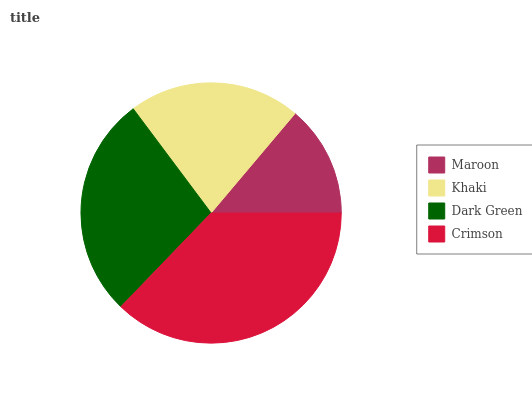Is Maroon the minimum?
Answer yes or no. Yes. Is Crimson the maximum?
Answer yes or no. Yes. Is Khaki the minimum?
Answer yes or no. No. Is Khaki the maximum?
Answer yes or no. No. Is Khaki greater than Maroon?
Answer yes or no. Yes. Is Maroon less than Khaki?
Answer yes or no. Yes. Is Maroon greater than Khaki?
Answer yes or no. No. Is Khaki less than Maroon?
Answer yes or no. No. Is Dark Green the high median?
Answer yes or no. Yes. Is Khaki the low median?
Answer yes or no. Yes. Is Crimson the high median?
Answer yes or no. No. Is Crimson the low median?
Answer yes or no. No. 